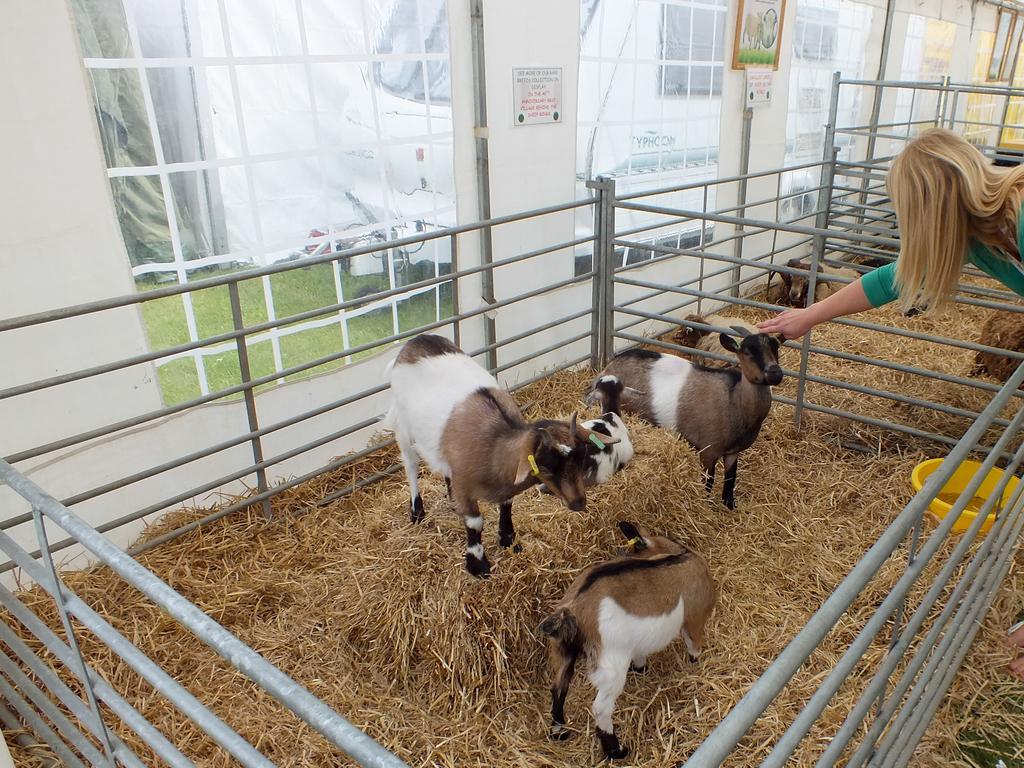Can you describe this image briefly? In this image I can see number of iron poles, dry grass and on it I can see few goats, a yellow colour container and few sheep. On the right side of the image I can see a woman and I can see she is wearing the green colour dress. In the background I can see few windows, few boards and on these boards I can see something is written. through the windows I can see a vehicle, grass and few other things. 